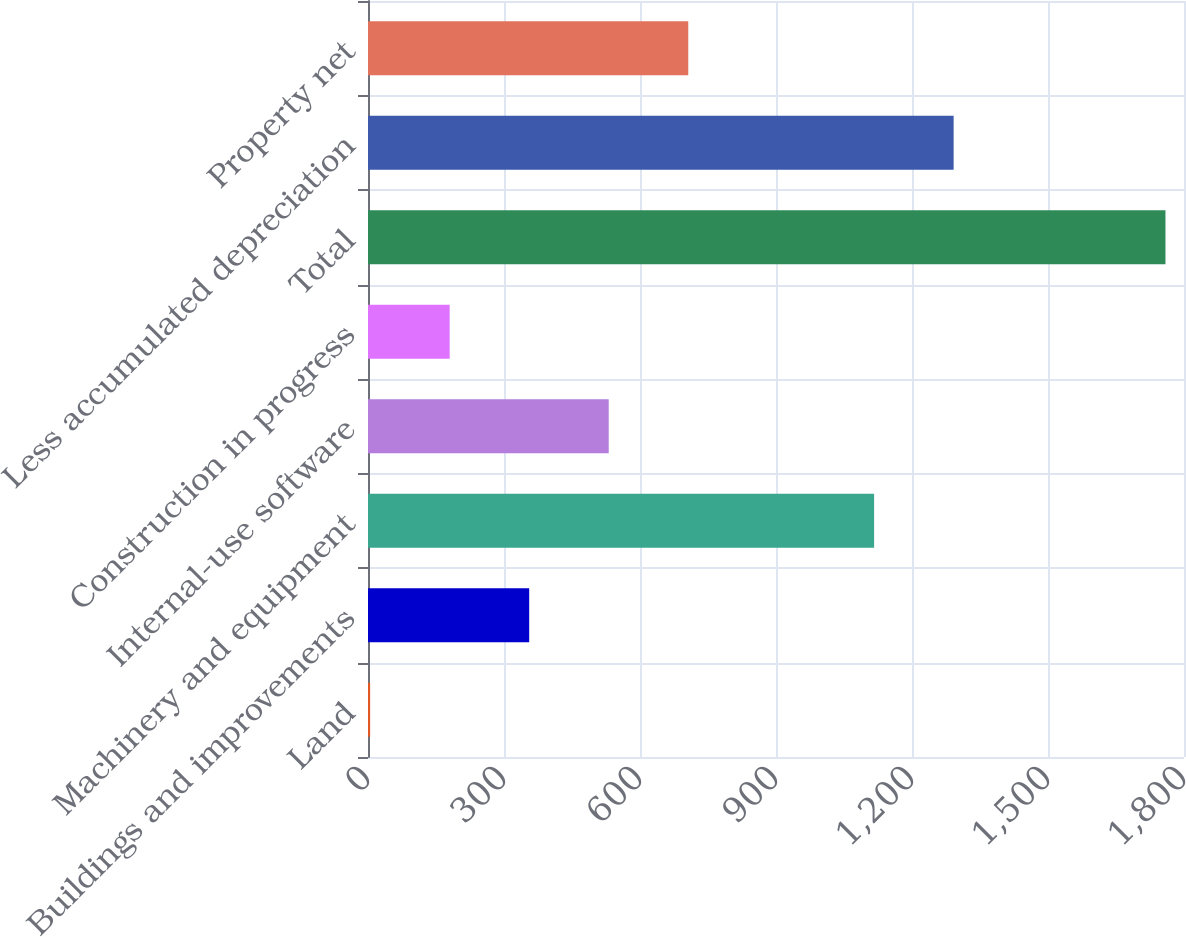Convert chart. <chart><loc_0><loc_0><loc_500><loc_500><bar_chart><fcel>Land<fcel>Buildings and improvements<fcel>Machinery and equipment<fcel>Internal-use software<fcel>Construction in progress<fcel>Total<fcel>Less accumulated depreciation<fcel>Property net<nl><fcel>4.7<fcel>355.58<fcel>1116.4<fcel>531.02<fcel>180.14<fcel>1759.1<fcel>1291.84<fcel>706.46<nl></chart> 